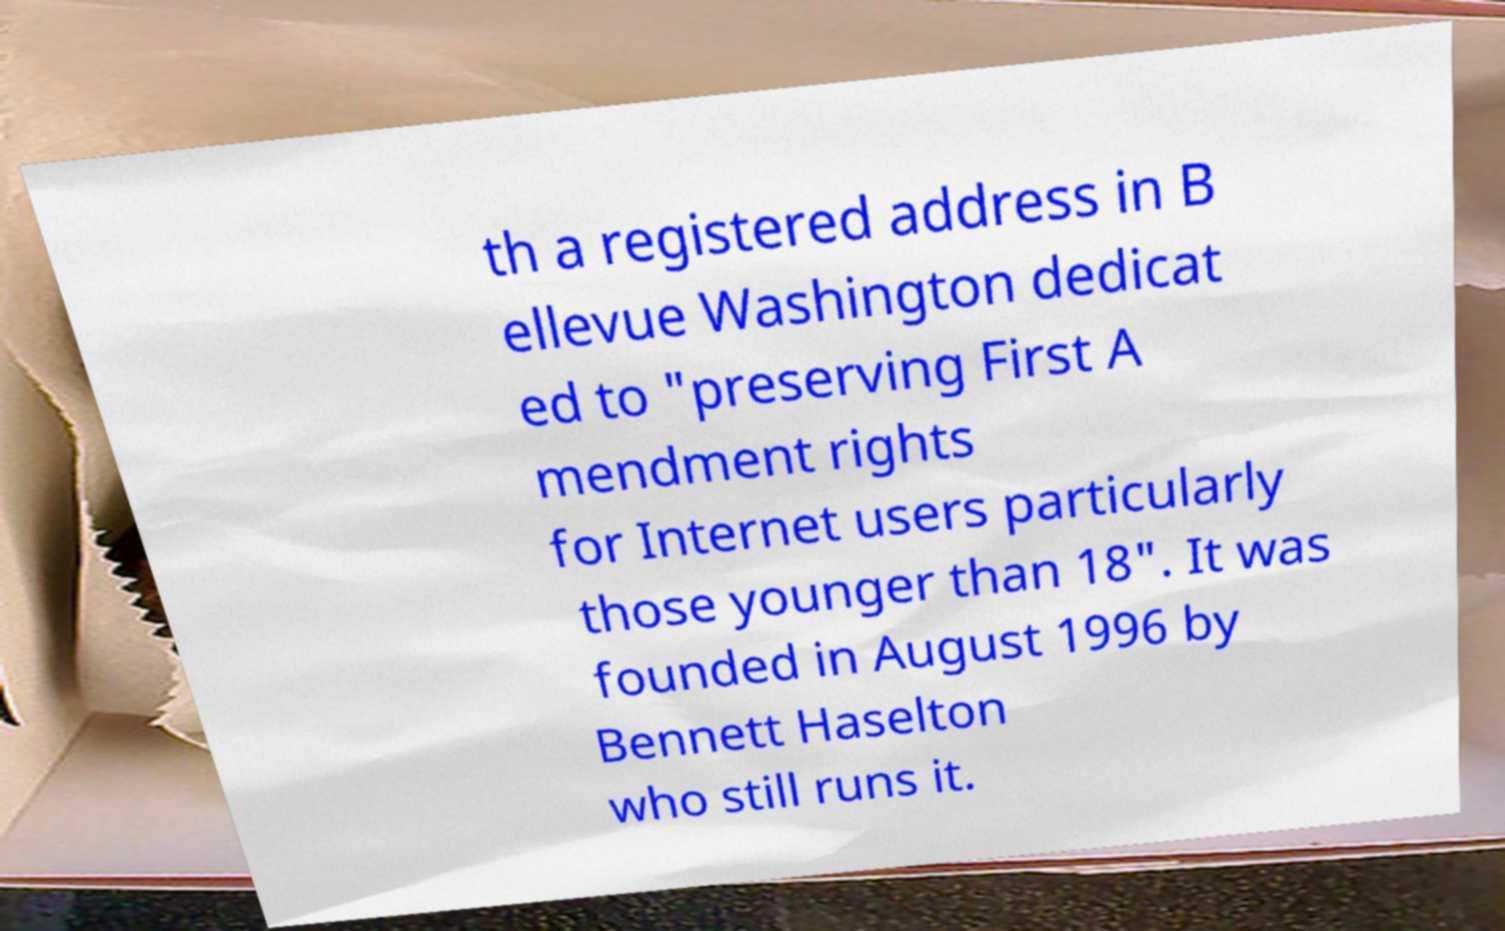Could you extract and type out the text from this image? th a registered address in B ellevue Washington dedicat ed to "preserving First A mendment rights for Internet users particularly those younger than 18". It was founded in August 1996 by Bennett Haselton who still runs it. 